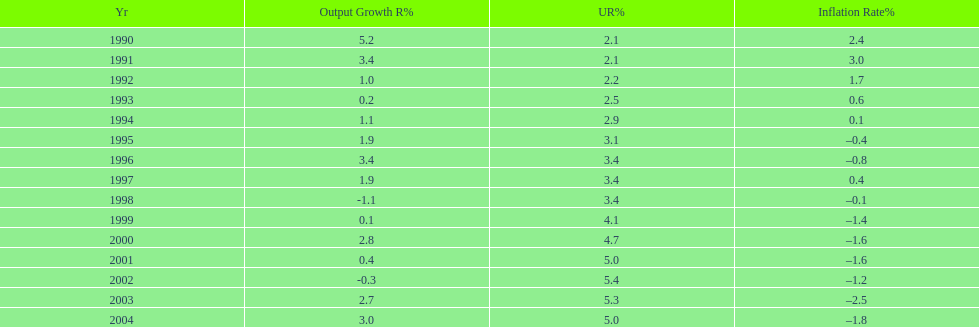When in the 1990's did the inflation rate first become negative? 1995. 